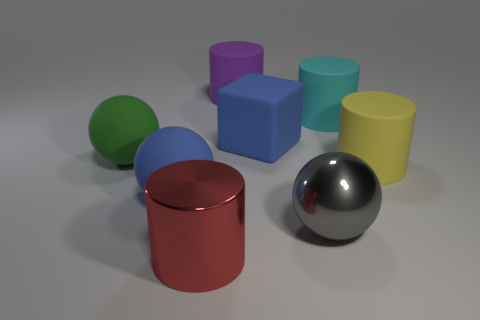How many things are either big purple objects or large gray rubber spheres?
Provide a short and direct response. 1. How many objects are the same color as the rubber block?
Keep it short and to the point. 1. What number of large red things have the same material as the green object?
Ensure brevity in your answer.  0. How many things are blocks or objects that are in front of the cyan matte thing?
Keep it short and to the point. 6. What color is the metallic object to the left of the ball that is right of the blue object left of the red thing?
Keep it short and to the point. Red. How many big things are either gray metallic things or blue rubber balls?
Keep it short and to the point. 2. What is the color of the cylinder that is both behind the yellow cylinder and on the left side of the metal sphere?
Give a very brief answer. Purple. Are there any big rubber objects of the same shape as the big gray metallic thing?
Make the answer very short. Yes. What material is the big gray sphere?
Make the answer very short. Metal. There is a big yellow rubber cylinder; are there any blue rubber balls to the left of it?
Keep it short and to the point. Yes. 